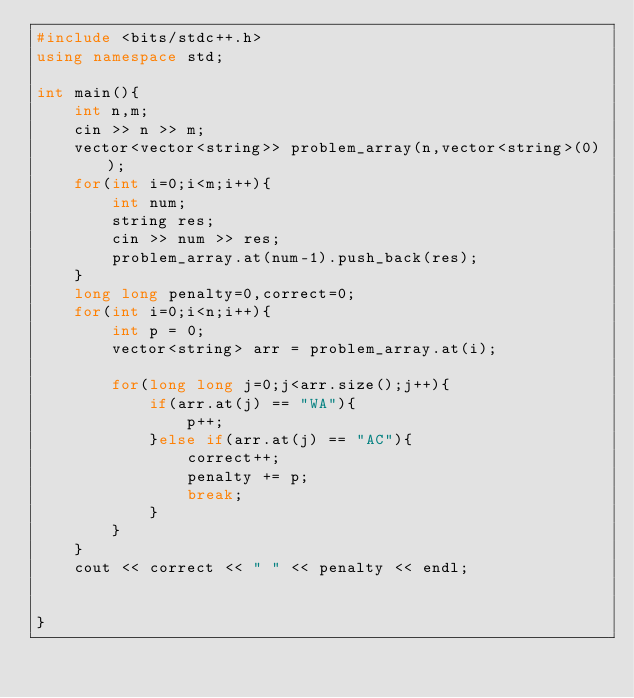<code> <loc_0><loc_0><loc_500><loc_500><_C++_>#include <bits/stdc++.h>
using namespace std;

int main(){
    int n,m;
    cin >> n >> m;
    vector<vector<string>> problem_array(n,vector<string>(0));
    for(int i=0;i<m;i++){
        int num;
        string res;
        cin >> num >> res;
        problem_array.at(num-1).push_back(res);
    }
    long long penalty=0,correct=0;
    for(int i=0;i<n;i++){
        int p = 0;
        vector<string> arr = problem_array.at(i);
        
        for(long long j=0;j<arr.size();j++){
            if(arr.at(j) == "WA"){
                p++;
            }else if(arr.at(j) == "AC"){
                correct++;
                penalty += p;
                break;
            }
        }
    }
    cout << correct << " " << penalty << endl;


}</code> 